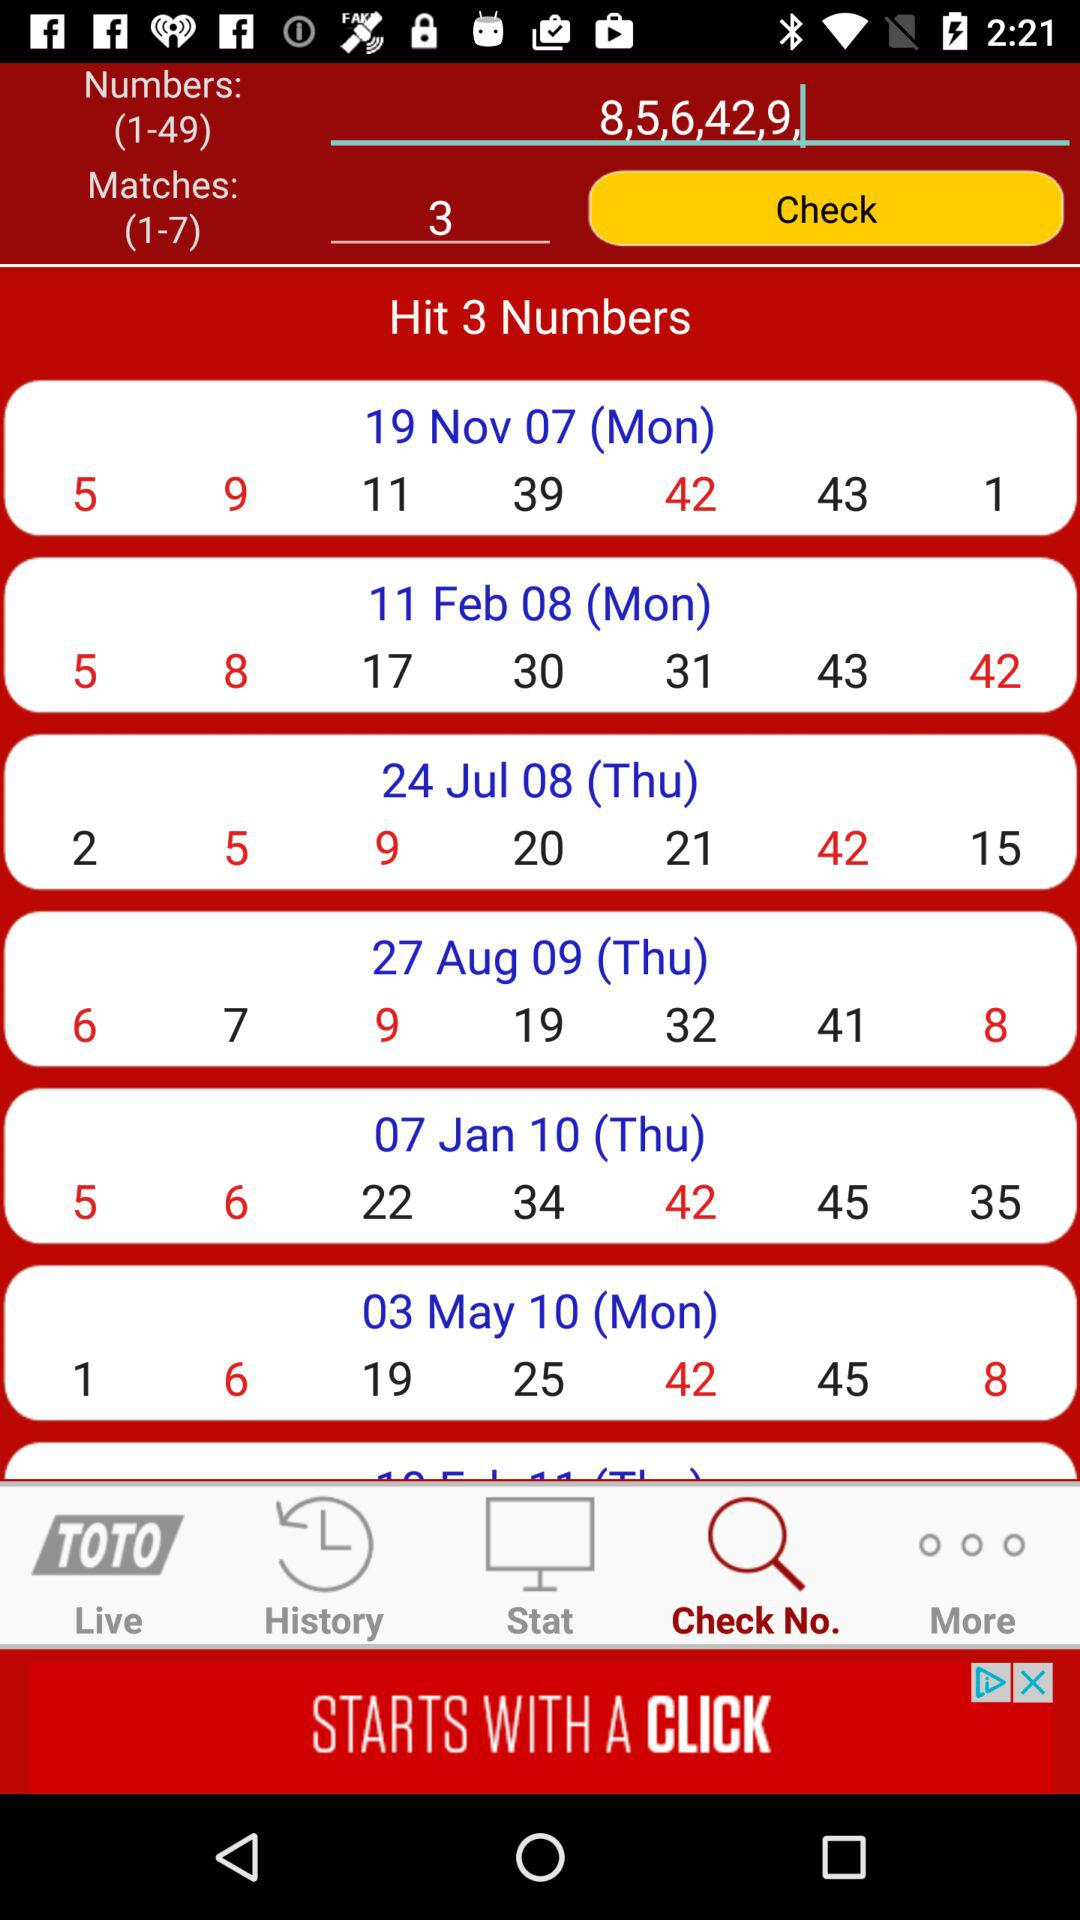How many matches are required?
Answer the question using a single word or phrase. 3 